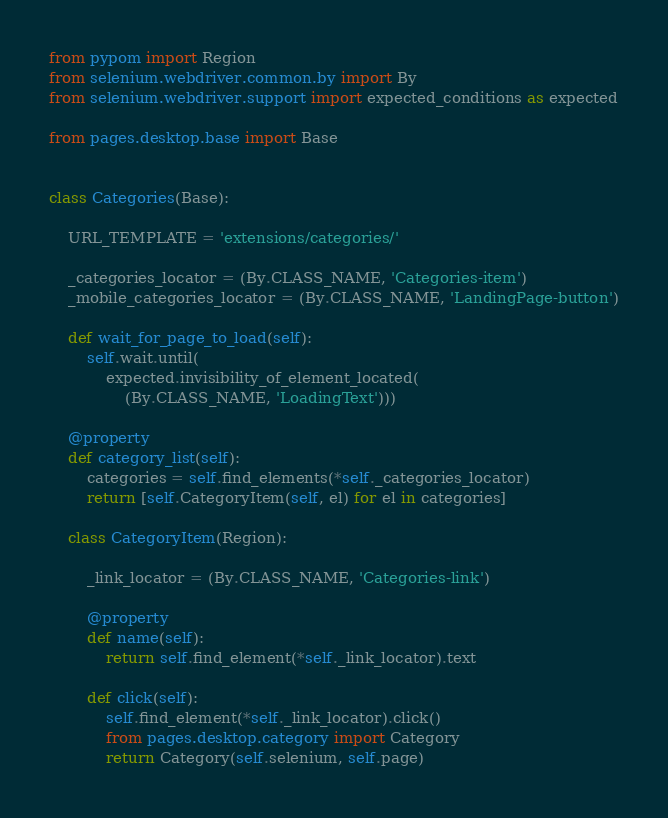<code> <loc_0><loc_0><loc_500><loc_500><_Python_>from pypom import Region
from selenium.webdriver.common.by import By
from selenium.webdriver.support import expected_conditions as expected

from pages.desktop.base import Base


class Categories(Base):

    URL_TEMPLATE = 'extensions/categories/'

    _categories_locator = (By.CLASS_NAME, 'Categories-item')
    _mobile_categories_locator = (By.CLASS_NAME, 'LandingPage-button')

    def wait_for_page_to_load(self):
        self.wait.until(
            expected.invisibility_of_element_located(
                (By.CLASS_NAME, 'LoadingText')))

    @property
    def category_list(self):
        categories = self.find_elements(*self._categories_locator)
        return [self.CategoryItem(self, el) for el in categories]

    class CategoryItem(Region):

        _link_locator = (By.CLASS_NAME, 'Categories-link')

        @property
        def name(self):
            return self.find_element(*self._link_locator).text

        def click(self):
            self.find_element(*self._link_locator).click()
            from pages.desktop.category import Category
            return Category(self.selenium, self.page)
</code> 